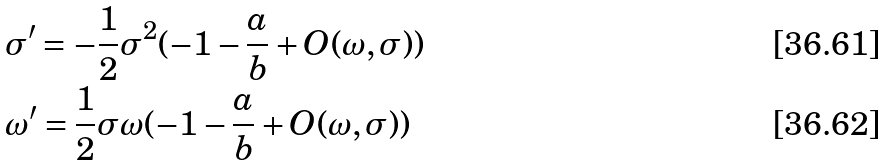Convert formula to latex. <formula><loc_0><loc_0><loc_500><loc_500>& \sigma ^ { \prime } = - \frac { 1 } { 2 } \sigma ^ { 2 } ( - 1 - \frac { a } { b } + O ( \omega , \sigma ) ) \\ & \omega ^ { \prime } = \frac { 1 } { 2 } \sigma \omega ( - 1 - \frac { a } { b } + O ( \omega , \sigma ) )</formula> 